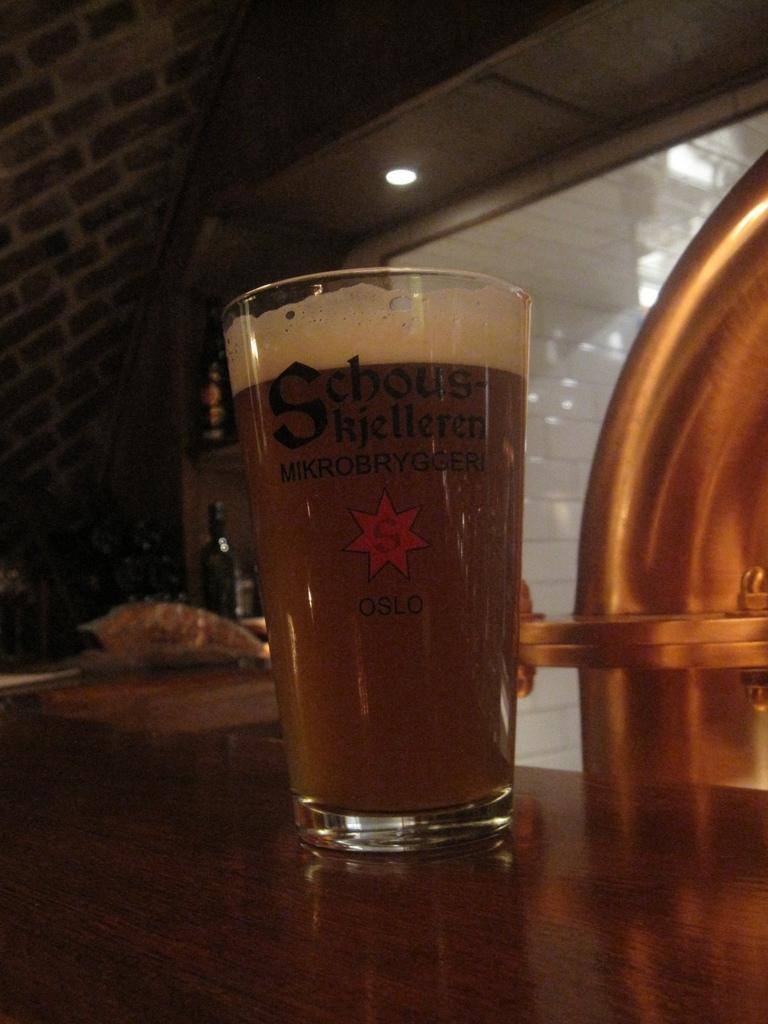Provide a one-sentence caption for the provided image. A glass of what looks like beer with Oslo written on it. 